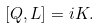Convert formula to latex. <formula><loc_0><loc_0><loc_500><loc_500>[ Q , L ] = i K .</formula> 